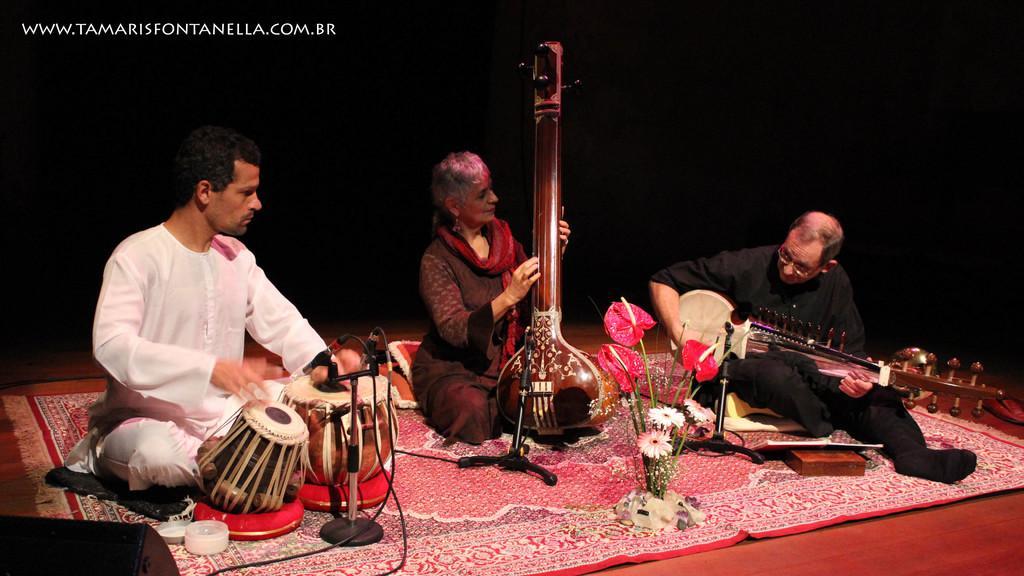Describe this image in one or two sentences. In this image there are three persons sitting on the carpet and playing the musical instruments like tabla, sitar , and there is dark background and a watermark on the image. 